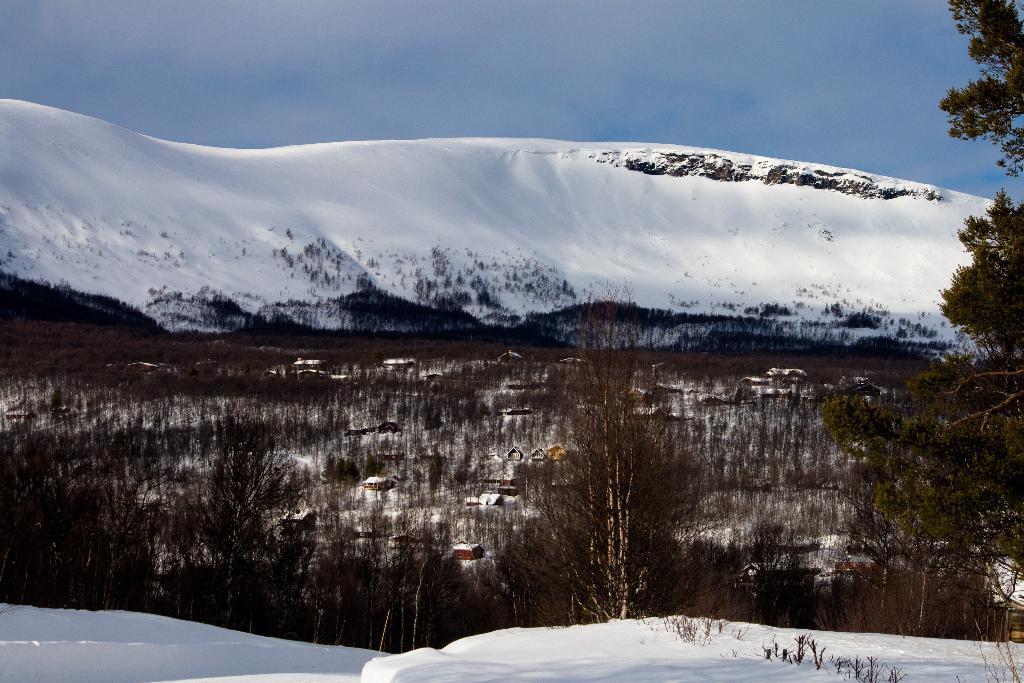Could you give a brief overview of what you see in this image? In the picture we can see the snow, mountains, trees, houses and the blue color sky in the background. 